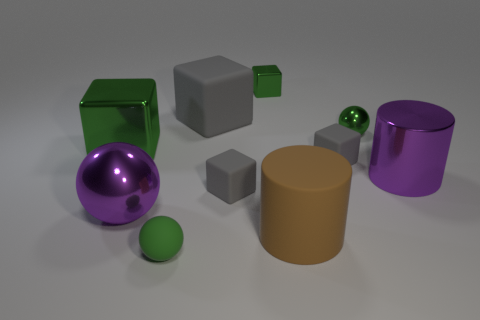There is a rubber object that is in front of the big brown rubber cylinder; is its color the same as the large metallic block?
Make the answer very short. Yes. What number of things are big brown rubber objects or tiny gray things that are in front of the metallic cylinder?
Your response must be concise. 2. Do the tiny object in front of the big matte cylinder and the brown object that is on the right side of the tiny green matte sphere have the same shape?
Offer a terse response. No. Is there anything else of the same color as the matte cylinder?
Make the answer very short. No. What is the shape of the green object that is the same material as the large brown thing?
Give a very brief answer. Sphere. There is a ball that is right of the big purple metallic sphere and behind the big brown rubber cylinder; what is its material?
Your response must be concise. Metal. Is the color of the large metal sphere the same as the metal cylinder?
Provide a short and direct response. Yes. There is a metallic object that is the same color as the large sphere; what is its shape?
Your answer should be compact. Cylinder. What number of purple shiny objects have the same shape as the brown thing?
Give a very brief answer. 1. The purple ball that is made of the same material as the large green block is what size?
Make the answer very short. Large. 